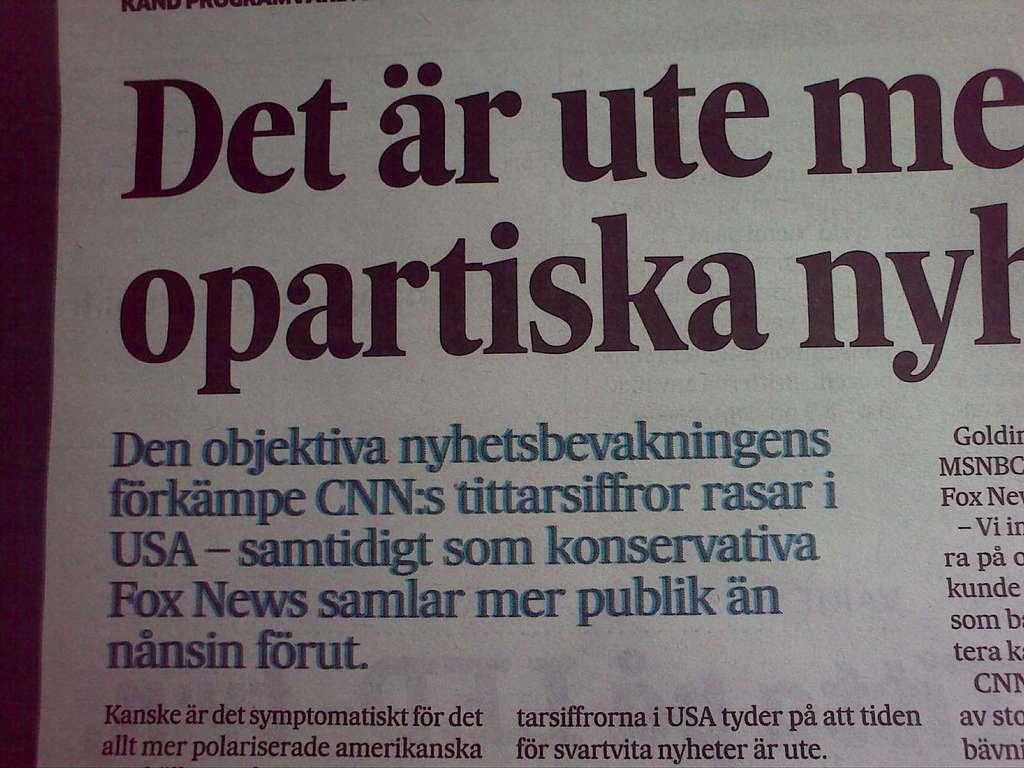<image>
Offer a succinct explanation of the picture presented. a newspaper article title det ar ute me 